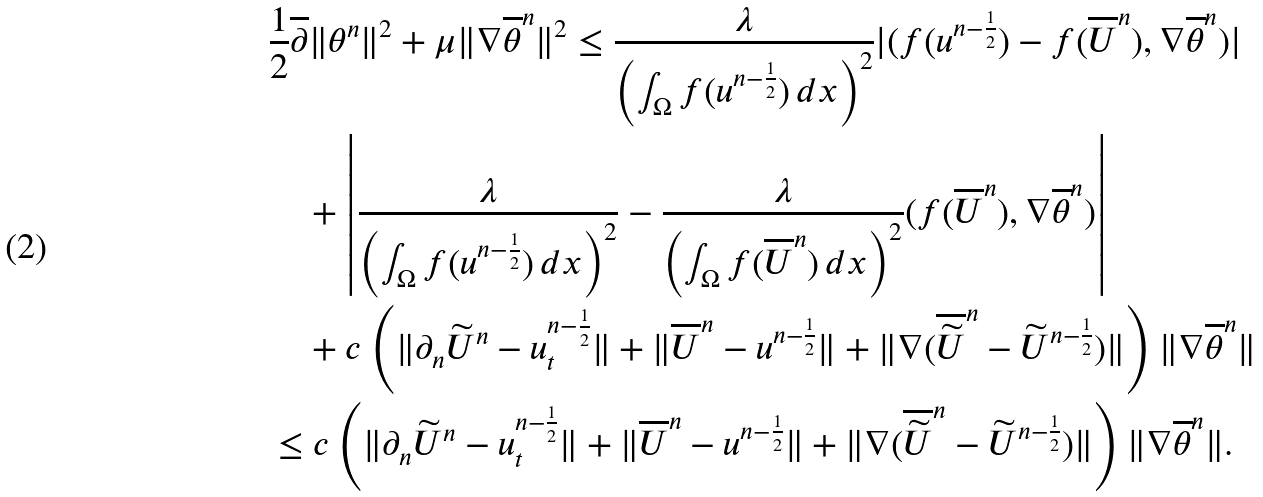<formula> <loc_0><loc_0><loc_500><loc_500>& \frac { 1 } { 2 } \overline { \partial } \| \theta ^ { n } \| ^ { 2 } + \mu \| \nabla \overline { \theta } ^ { n } \| ^ { 2 } \leq \frac { \lambda } { \left ( \int _ { \Omega } f ( u ^ { n - \frac { 1 } { 2 } } ) \, d x \right ) ^ { 2 } } | ( f ( u ^ { n - \frac { 1 } { 2 } } ) - f ( \overline { U } ^ { n } ) , \nabla \overline { \theta } ^ { n } ) | \\ & \quad + \left | \frac { \lambda } { \left ( \int _ { \Omega } f ( u ^ { n - \frac { 1 } { 2 } } ) \, d x \right ) ^ { 2 } } - \frac { \lambda } { \left ( \int _ { \Omega } f ( \overline { U } ^ { n } ) \, d x \right ) ^ { 2 } } ( f ( \overline { U } ^ { n } ) , \nabla \overline { \theta } ^ { n } ) \right | \\ & \quad + c \left ( \| \partial _ { n } \widetilde { U } ^ { n } - u _ { t } ^ { n - \frac { 1 } { 2 } } \| + \| \overline { U } ^ { n } - u ^ { n - \frac { 1 } { 2 } } \| + \| \nabla ( \overline { \widetilde { U } } ^ { n } - \widetilde { U } ^ { n - \frac { 1 } { 2 } } ) \| \right ) \| \nabla \overline { \theta } ^ { n } \| \\ & \leq c \left ( \| \partial _ { n } \widetilde { U } ^ { n } - u _ { t } ^ { n - \frac { 1 } { 2 } } \| + \| \overline { U } ^ { n } - u ^ { n - \frac { 1 } { 2 } } \| + \| \nabla ( \overline { \widetilde { U } } ^ { n } - \widetilde { U } ^ { n - \frac { 1 } { 2 } } ) \| \right ) \| \nabla \overline { \theta } ^ { n } \| .</formula> 